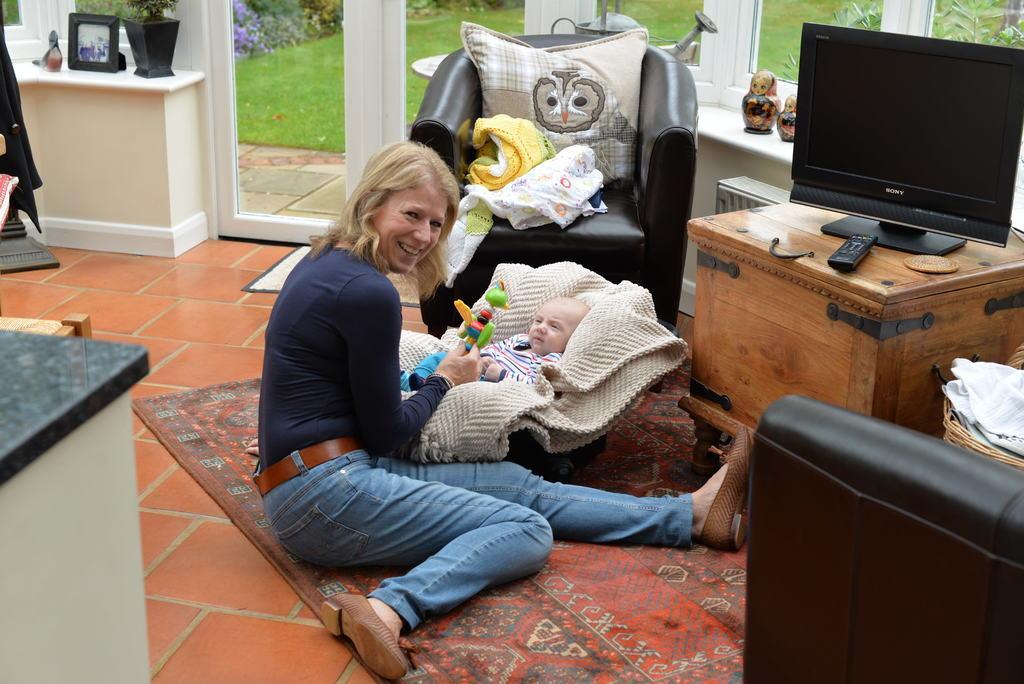Describe this image in one or two sentences. In the image we can see there is a woman who is sitting and she is holding a toy and there is a baby who is lying on the cloth and on the table there is a tv with a tv remote. 